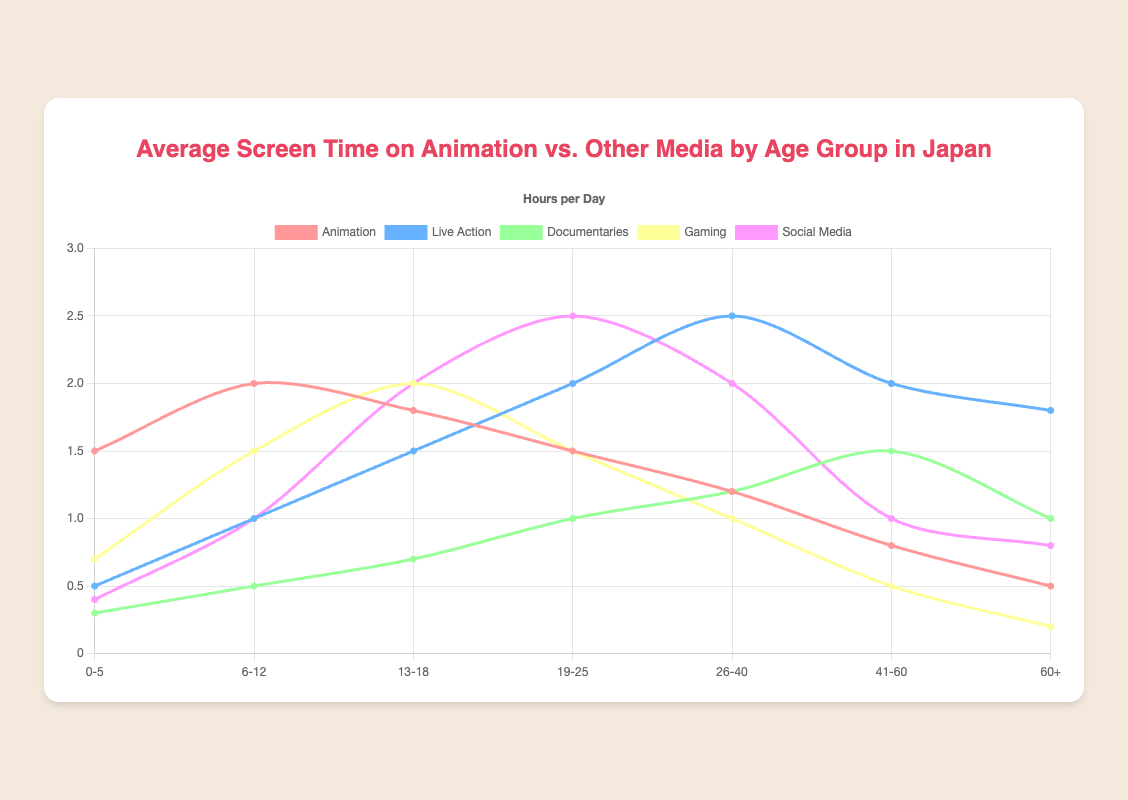What age group spends the most time on animation per day? Look for the highest point in the Animation line. The highest value is 2.0 hours per day in the 6-12 age group.
Answer: 6-12 Which age group has the least screen time for documentaries? Identify the lowest point in the Documentaries line, which is 0.3 hours per day for the 0-5 age group.
Answer: 0-5 How does the screen time for social media change from the 13-18 age group to the 19-25 age group? Check the Social Media line between the 13-18 and 19-25 age groups. It increases from 2.0 hours to 2.5 hours.
Answer: Increases Which media type shows a decrease in screen time as age increases from 0-5 to 60+? Compare the different lines across age groups. Animation shows a continual decrease from 1.5 hours to 0.5 hours as age increases from 0-5 to 60+.
Answer: Animation What is the combined average screen time for gaming and live action in the 19-25 age group? Add the values for gaming and live action in the 19-25 group: 1.5 (gaming) + 2.0 (live action) = 3.5 hours per day.
Answer: 3.5 Which age group shows the maximum screen time for live action, and what is the value? Look for the highest point in the Live Action line. It's 2.5 hours per day for the 26-40 age group.
Answer: 26-40, 2.5 hours Does screen time for gaming ever exceed that for animation in any age group? Compare values in the Gaming and Animation lines for each age group. In the 13-18 age group, gaming time is 2.0 hours, while animation is 1.8 hours, indicating an instance where gaming exceeds animation.
Answer: Yes Is there any age group where documentaries have the same screen time as gaming? If so, which one, and what's the value? Check if any of the two lines intersect. For the 0-5 age group, both documentaries and gaming have screen times of 0.3 hours.
Answer: Yes, 0-5, 0.3 hours 